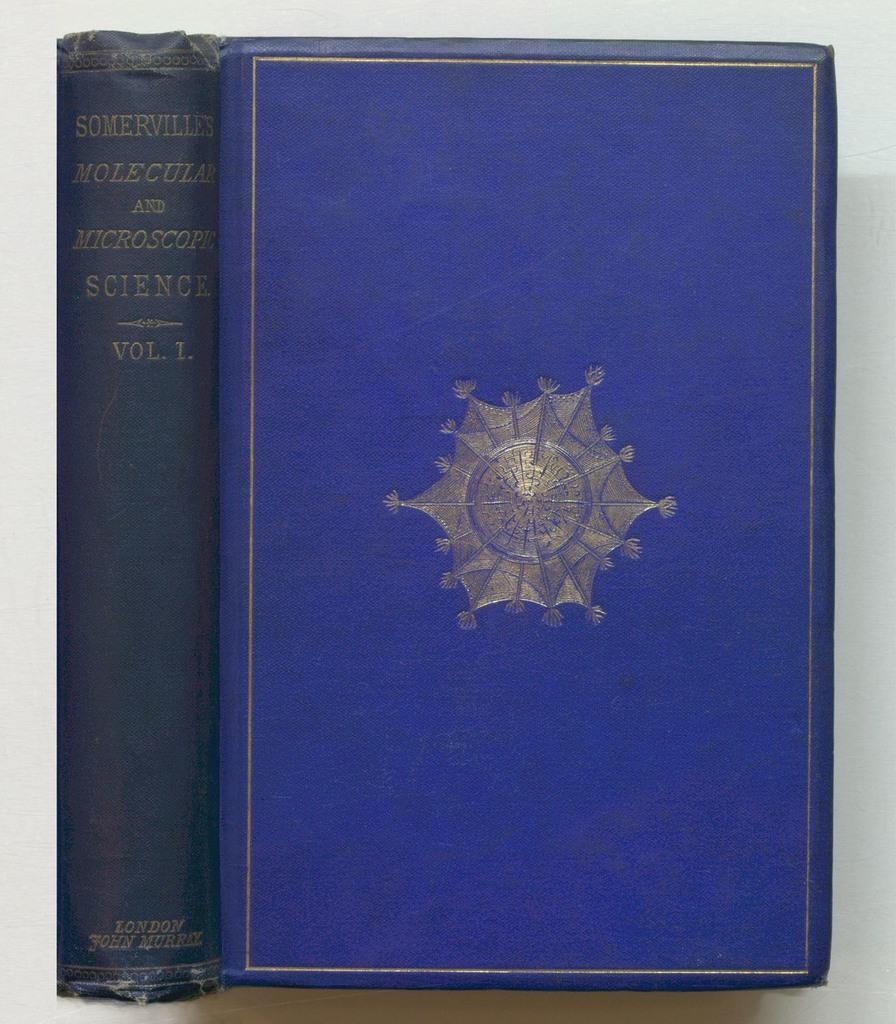<image>
Provide a brief description of the given image. Volume 1 of a science book written in a foreign language by John Murrel. 